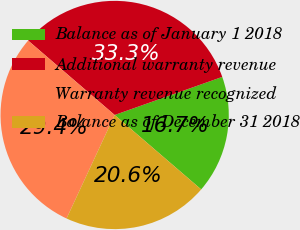<chart> <loc_0><loc_0><loc_500><loc_500><pie_chart><fcel>Balance as of January 1 2018<fcel>Additional warranty revenue<fcel>Warranty revenue recognized<fcel>Balance as of December 31 2018<nl><fcel>16.72%<fcel>33.28%<fcel>29.38%<fcel>20.62%<nl></chart> 